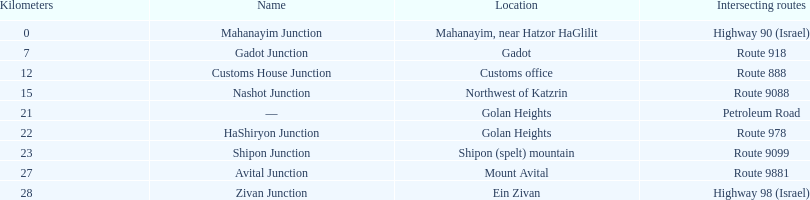Which crossroad on highway 91 is closer to ein zivan, gadot crossroad or shipon crossroad? Gadot Junction. 